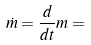<formula> <loc_0><loc_0><loc_500><loc_500>\dot { m } = \frac { d } { d t } m =</formula> 